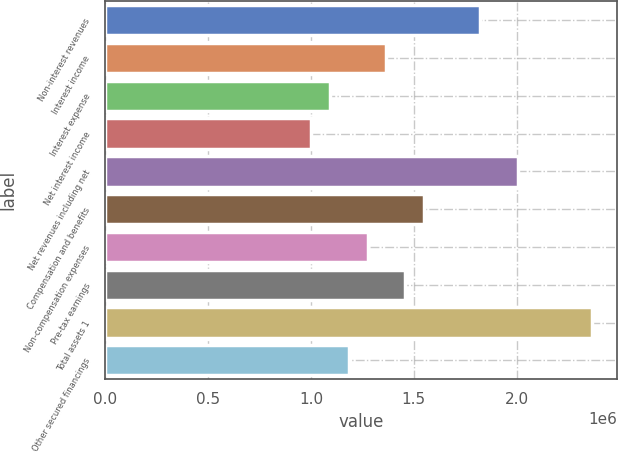Convert chart to OTSL. <chart><loc_0><loc_0><loc_500><loc_500><bar_chart><fcel>Non-interest revenues<fcel>Interest income<fcel>Interest expense<fcel>Net interest income<fcel>Net revenues including net<fcel>Compensation and benefits<fcel>Non-compensation expenses<fcel>Pre-tax earnings<fcel>Total assets 1<fcel>Other secured financings<nl><fcel>1.82225e+06<fcel>1.36668e+06<fcel>1.09335e+06<fcel>1.00224e+06<fcel>2.00447e+06<fcel>1.54891e+06<fcel>1.27557e+06<fcel>1.4578e+06<fcel>2.36892e+06<fcel>1.18446e+06<nl></chart> 